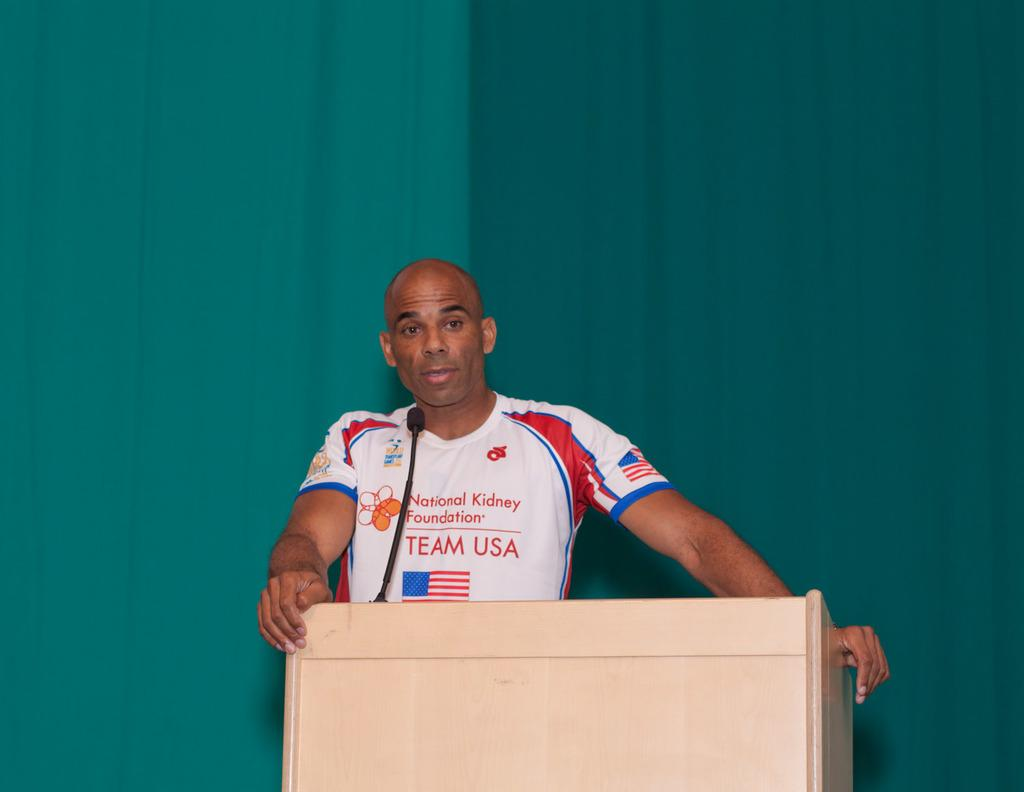Who or what is present in the image? There is a person in the image. What object can be seen near the person? There is a podium in the image. What device is visible in the image that might be used for speaking? There is a microphone in the image. What can be seen behind the person and the podium? There is a wall in the background of the image. What type of prose can be heard being read from the podium in the image? There is no indication of any prose being read in the image, as it only shows a person, a podium, a microphone, and a wall. 